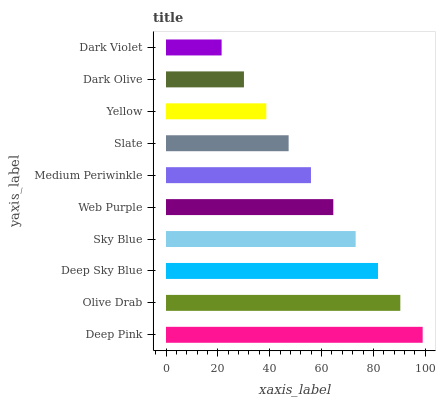Is Dark Violet the minimum?
Answer yes or no. Yes. Is Deep Pink the maximum?
Answer yes or no. Yes. Is Olive Drab the minimum?
Answer yes or no. No. Is Olive Drab the maximum?
Answer yes or no. No. Is Deep Pink greater than Olive Drab?
Answer yes or no. Yes. Is Olive Drab less than Deep Pink?
Answer yes or no. Yes. Is Olive Drab greater than Deep Pink?
Answer yes or no. No. Is Deep Pink less than Olive Drab?
Answer yes or no. No. Is Web Purple the high median?
Answer yes or no. Yes. Is Medium Periwinkle the low median?
Answer yes or no. Yes. Is Dark Violet the high median?
Answer yes or no. No. Is Olive Drab the low median?
Answer yes or no. No. 